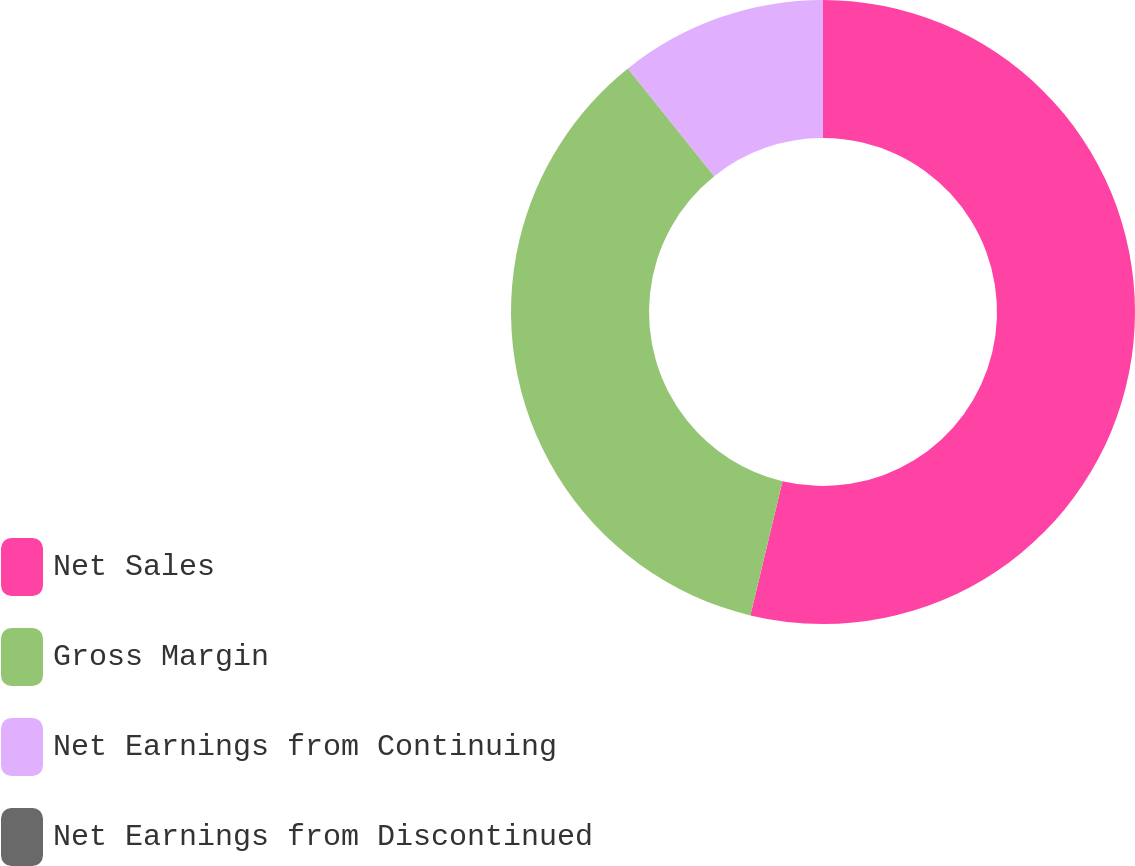Convert chart to OTSL. <chart><loc_0><loc_0><loc_500><loc_500><pie_chart><fcel>Net Sales<fcel>Gross Margin<fcel>Net Earnings from Continuing<fcel>Net Earnings from Discontinued<nl><fcel>53.74%<fcel>35.51%<fcel>10.75%<fcel>0.0%<nl></chart> 